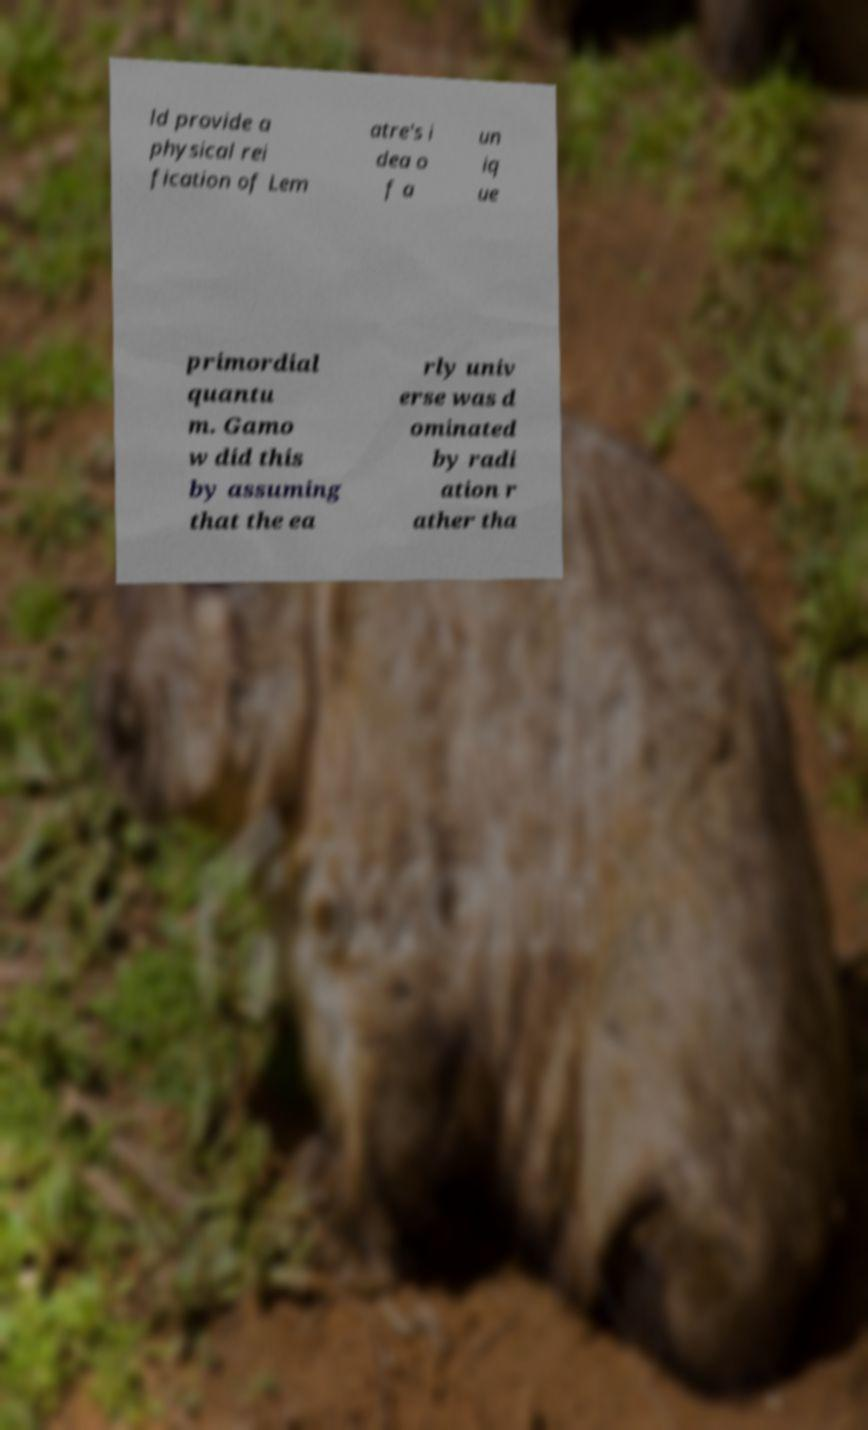Can you read and provide the text displayed in the image?This photo seems to have some interesting text. Can you extract and type it out for me? ld provide a physical rei fication of Lem atre's i dea o f a un iq ue primordial quantu m. Gamo w did this by assuming that the ea rly univ erse was d ominated by radi ation r ather tha 